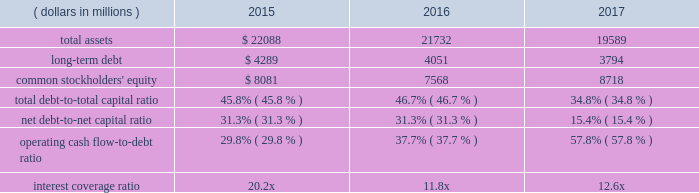Operating cash flow from continuing operations for 2017 was $ 2.7 billion , a $ 191 million , or 8 percent increase compared with 2016 , reflecting higher earnings and favorable changes in working capital .
Operating cash flow from continuing operations of $ 2.5 billion in 2016 was a 23 percent increase compared to $ 2.0 billion in 2015 , as comparisons benefited from income taxes of $ 424 million paid on the gains from divestitures in 2015 .
At september 30 , 2017 , operating working capital as a percent of sales increased to 6.6 percent due to higher levels of working capital in the acquired valves & controls business , compared with 5.2 percent and 7.2 percent in 2016 and 2015 , respectively .
Operating cash flow from continuing operations funded capital expenditures of $ 476 million , dividends of $ 1239 million , common stock purchases of $ 400 million , and was also used to partially pay down debt in 2017 .
Proceeds of $ 5.1 billion from the sales of the network power systems and power generation , motors and drives businesses funded acquisitions of $ 2990 million , cash used for discontinued operations of $ 778 million and repayments of short-term borrowings and long-term debt of approximately $ 1.3 billion .
Contributions to pension plans were $ 45 million in 2017 , $ 66 million in 2016 and $ 53 million in 2015 .
Capital expenditures related to continuing operations were $ 476 million , $ 447 million and $ 588 million in 2017 , 2016 and 2015 , respectively .
Free cash flow from continuing operations ( operating cash flow less capital expenditures ) was $ 2.2 billion in 2017 , up 8 percent .
Free cash flow was $ 2.1 billion in 2016 , compared with $ 1.5 billion in 2015 .
The company is targeting capital spending of approximately $ 550 million in 2018 .
Net cash paid in connection with acquisitions was $ 2990 million , $ 132 million and $ 324 million in 2017 , 2016 and 2015 , respectively .
Proceeds from divestitures not classified as discontinued operations were $ 39 million in 2017 and $ 1812 million in 2015 .
Dividends were $ 1239 million ( $ 1.92 per share ) in 2017 , compared with $ 1227 million ( $ 1.90 per share ) in 2016 and $ 1269 million ( $ 1.88 per share ) in 2015 .
In november 2017 , the board of directors voted to increase the quarterly cash dividend 1 percent , to an annualized rate of $ 1.94 per share .
Purchases of emerson common stock totaled $ 400 million , $ 601 million and $ 2487 million in 2017 , 2016 and 2015 , respectively , at average per share prices of $ 60.51 , $ 48.11 and $ 57.68 .
The board of directors authorized the purchase of up to 70 million common shares in november 2015 , and 56.9 million shares remain available for purchase under this authorization .
The company purchased 6.6 million shares in 2017 under the november 2015 authorization .
In 2016 , the company purchased 12.5 million shares under a combination of the november 2015 authorization and the remainder of the may 2013 authorization .
A total of 43.1 million shares were purchased in 2015 under the may 2013 authorization .
Leverage/capitalization ( dollars in millions ) 2015 2016 2017 .
Total debt , which includes long-term debt , current maturities of long-term debt , commercial paper and other short-term borrowings , was $ 4.7 billion , $ 6.6 billion and $ 6.8 billion for 2017 , 2016 and 2015 , respectively .
During the year , the company repaid $ 250 million of 5.125% ( 5.125 % ) notes that matured in december 2016 .
In 2015 , the company issued $ 500 million of 2.625% ( 2.625 % ) notes due december 2021 and $ 500 million of 3.150% ( 3.150 % ) notes due june 2025 , and repaid $ 250 million of 5.0% ( 5.0 % ) notes that matured in december 2014 and $ 250 million of 4.125% ( 4.125 % ) notes that matured in april 2015 .
The total debt-to-capital ratio and the net debt-to-net capital ratio ( less cash and short-term investments ) decreased in 2017 due to lower total debt outstanding and higher common stockholders 2019 equity from changes in other comprehensive income .
The total debt-to-capital ratio and the net debt-to-net capital ratio ( less cash and short-term investments ) increased in 2016 due to lower common stockholders 2019 equity from share repurchases and changes in other comprehensive income .
The operating cash flow from continuing operations-to-debt ratio increased in 2017 primarily due to lower debt in the current year .
The operating cash flow from continuing operations-to- debt ratio increased in 2016 primarily due to taxes paid in 2015 on the divestiture gains and lower debt in 2016 .
The interest coverage ratio is computed as earnings from continuing operations before income taxes plus interest expense , divided by interest expense .
The increase in interest coverage in 2017 reflects lower interest expense in the current year .
The decrease in interest coverage in 2016 reflects lower pretax earnings , largely due to the divestiture gains of $ 1039 million in 2015 , and slightly higher interest expense .
In april 2014 , the company entered into a $ 3.5 billion five- year revolving backup credit facility with various banks , which replaced the december 2010 $ 2.75 billion facility .
The credit facility is maintained to support general corporate purposes , including commercial paper borrowing .
The company has not incurred any borrowings under this or previous facilities .
The credit facility contains no financial covenants and is not subject to termination based on a change of credit rating or material adverse changes .
The facility is unsecured and may be accessed under various interest rate and currency denomination alternatives at the company 2019s option .
Fees to maintain the facility are immaterial .
The company also maintains a universal shelf registration statement on file with the sec under which .
What percentage of total debt was long-term debt in 2017? 
Computations: (3794 / (4.7 * 1000))
Answer: 0.80723. 